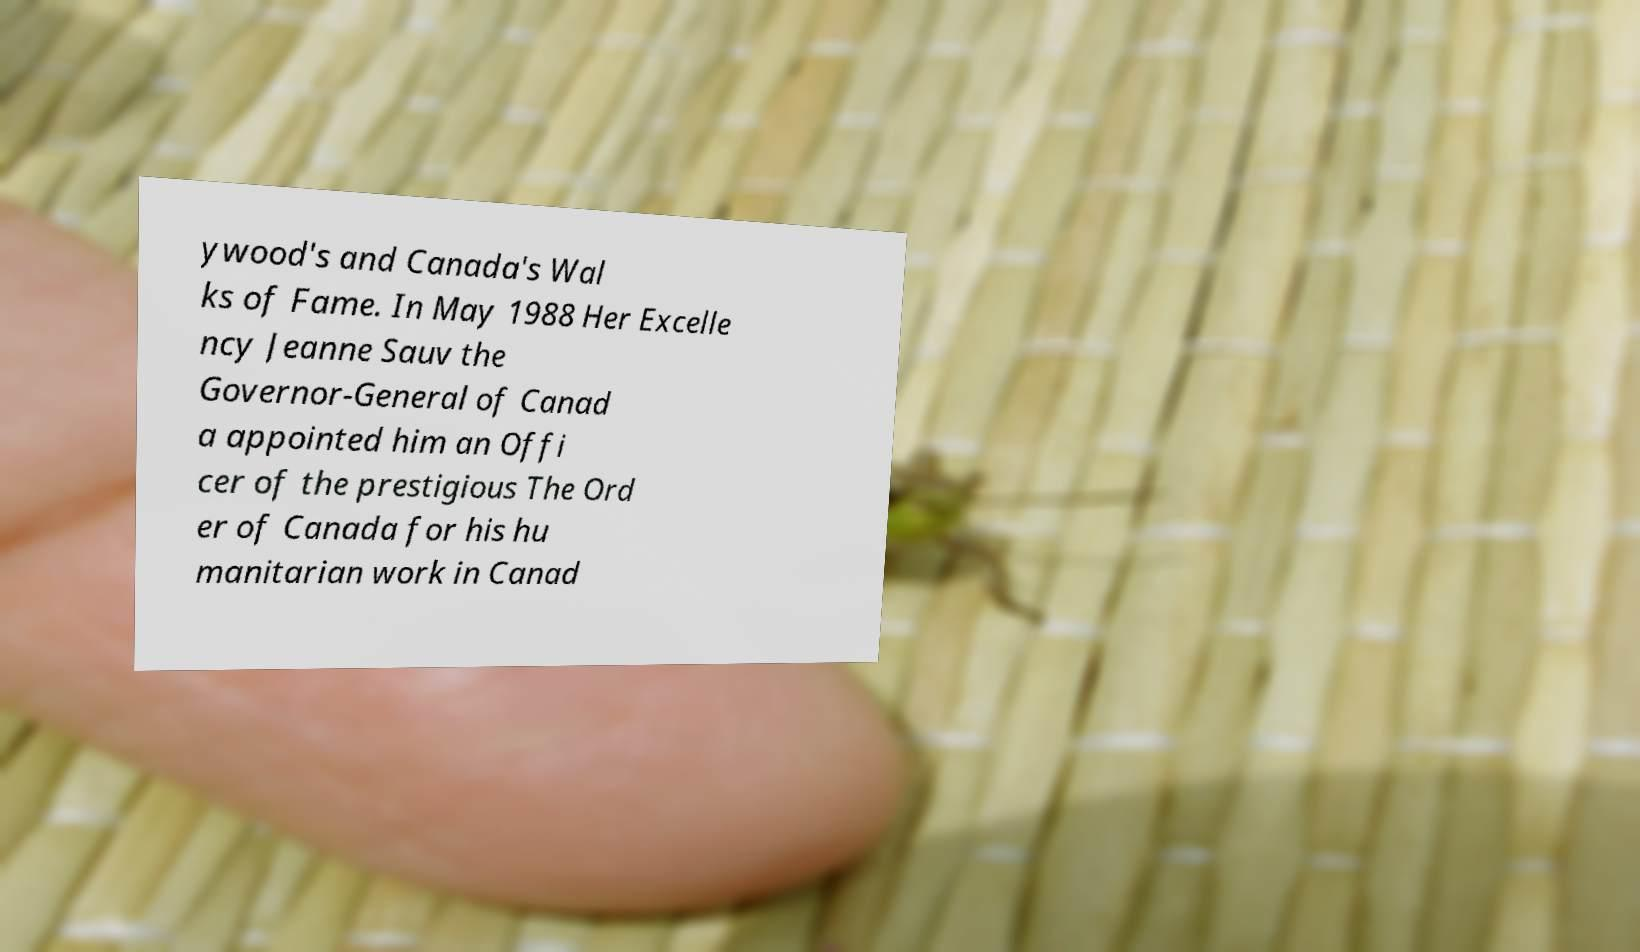Can you read and provide the text displayed in the image?This photo seems to have some interesting text. Can you extract and type it out for me? ywood's and Canada's Wal ks of Fame. In May 1988 Her Excelle ncy Jeanne Sauv the Governor-General of Canad a appointed him an Offi cer of the prestigious The Ord er of Canada for his hu manitarian work in Canad 